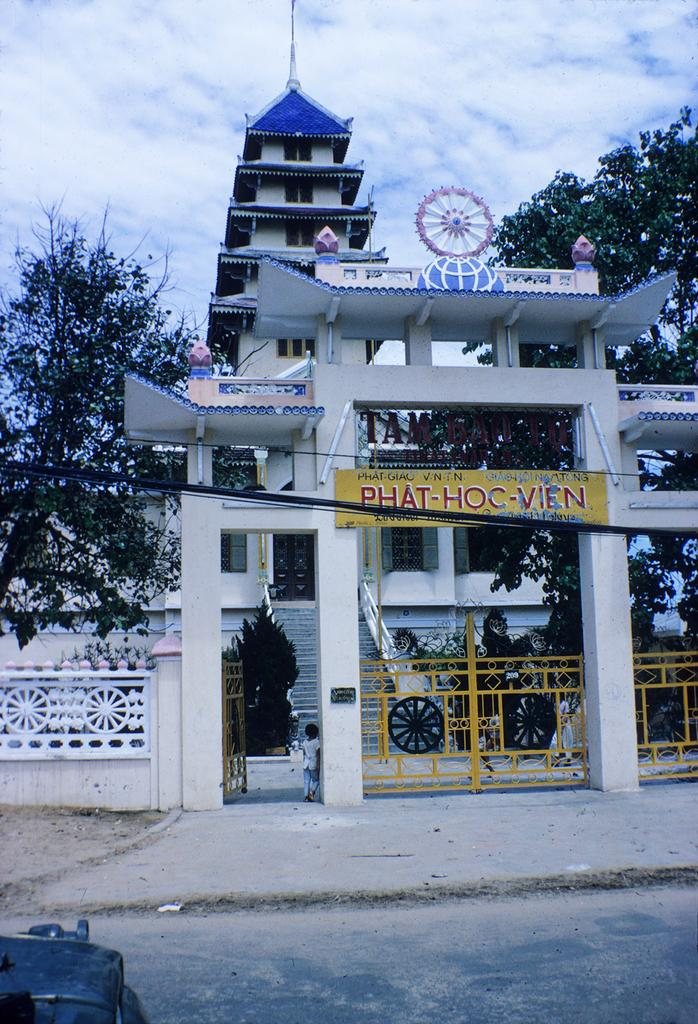What type of structure is present in the image? There is a building in the image. What other elements can be seen in the image? There are trees in the image. Can you describe the position of the child in the image? A child is standing in the entrance of the building. What else is visible at the bottom left side of the image? There appears to be a vehicle at the bottom left side of the image. How many fingers does the child have in the image? The image does not show the child's fingers, so it cannot be determined from the image. 